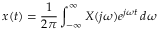Convert formula to latex. <formula><loc_0><loc_0><loc_500><loc_500>x ( t ) = { \frac { 1 } { 2 \pi } } \int _ { - \infty } ^ { \infty } X ( j \omega ) e ^ { j \omega t } \, d \omega</formula> 